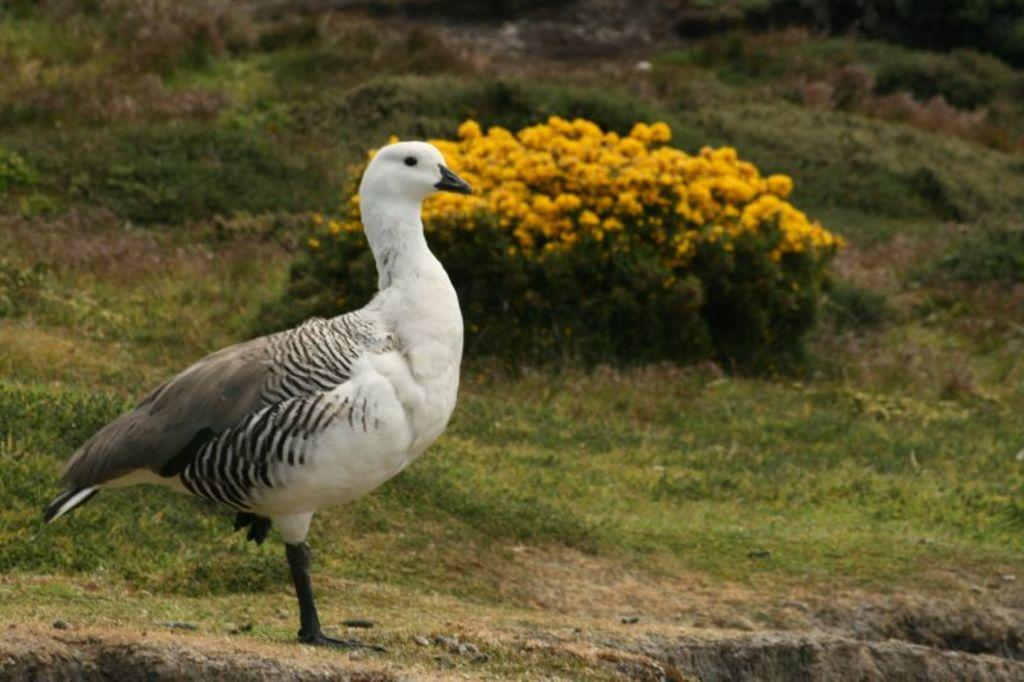What type of animal is in the image? There is a bird in the image. What colors can be seen on the bird? The bird has white and gray colors. What can be seen in the background of the image? There are flowers and plants in the background of the image. What color are the flowers? The flowers are yellow in color. What color are the plants? The plants are green in color. How does the bird's health appear in the image? The image does not provide any information about the bird's health. 